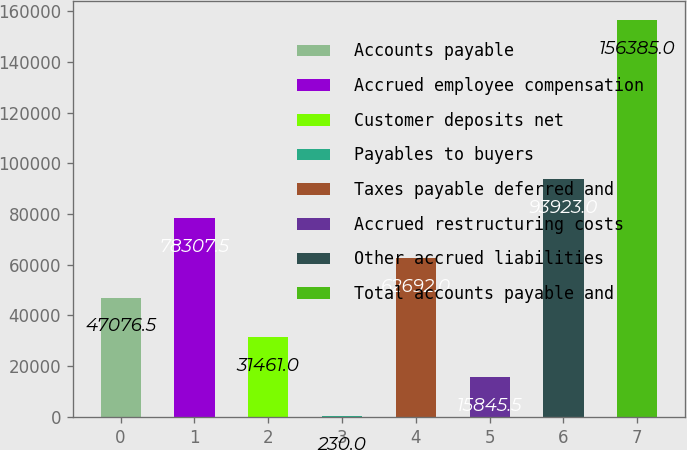<chart> <loc_0><loc_0><loc_500><loc_500><bar_chart><fcel>Accounts payable<fcel>Accrued employee compensation<fcel>Customer deposits net<fcel>Payables to buyers<fcel>Taxes payable deferred and<fcel>Accrued restructuring costs<fcel>Other accrued liabilities<fcel>Total accounts payable and<nl><fcel>47076.5<fcel>78307.5<fcel>31461<fcel>230<fcel>62692<fcel>15845.5<fcel>93923<fcel>156385<nl></chart> 